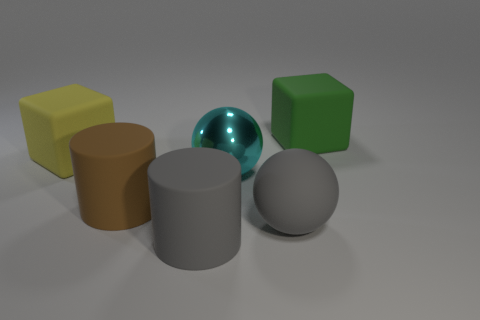There is a rubber ball; does it have the same size as the rubber thing that is on the right side of the matte ball?
Ensure brevity in your answer.  Yes. What is the size of the gray matte object that is the same shape as the metallic thing?
Ensure brevity in your answer.  Large. There is a matte cube that is right of the ball behind the big gray sphere; what number of big gray balls are to the right of it?
Make the answer very short. 0. What number of spheres are purple matte objects or large cyan objects?
Give a very brief answer. 1. The big block that is right of the large rubber cube that is in front of the big rubber block behind the yellow cube is what color?
Offer a very short reply. Green. How many other objects are the same size as the green block?
Your response must be concise. 5. Is there any other thing that has the same shape as the metallic object?
Your response must be concise. Yes. The other big matte thing that is the same shape as the yellow object is what color?
Give a very brief answer. Green. What color is the ball that is the same material as the big brown cylinder?
Your response must be concise. Gray. Are there an equal number of shiny things that are right of the large green thing and purple balls?
Provide a succinct answer. Yes. 